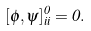Convert formula to latex. <formula><loc_0><loc_0><loc_500><loc_500>[ \phi , \psi ] ^ { 0 } _ { i i } = 0 .</formula> 